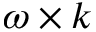Convert formula to latex. <formula><loc_0><loc_0><loc_500><loc_500>\omega \times k</formula> 